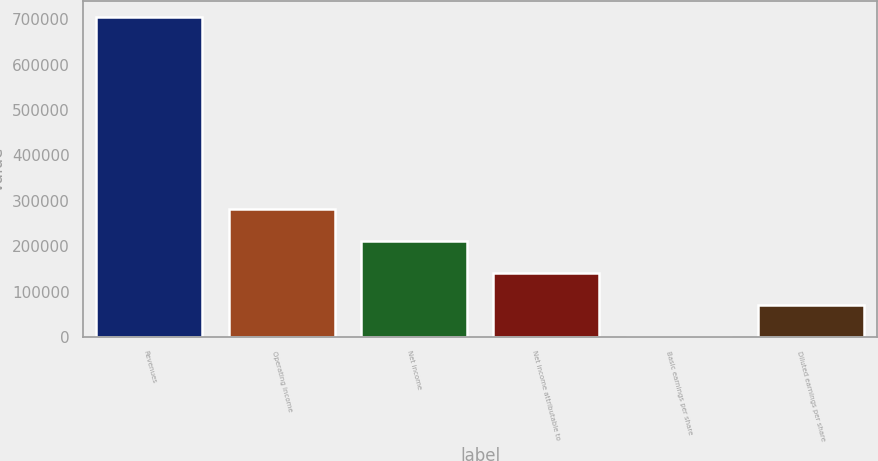<chart> <loc_0><loc_0><loc_500><loc_500><bar_chart><fcel>Revenues<fcel>Operating income<fcel>Net income<fcel>Net income attributable to<fcel>Basic earnings per share<fcel>Diluted earnings per share<nl><fcel>704895<fcel>281958<fcel>211469<fcel>140979<fcel>0.55<fcel>70490<nl></chart> 